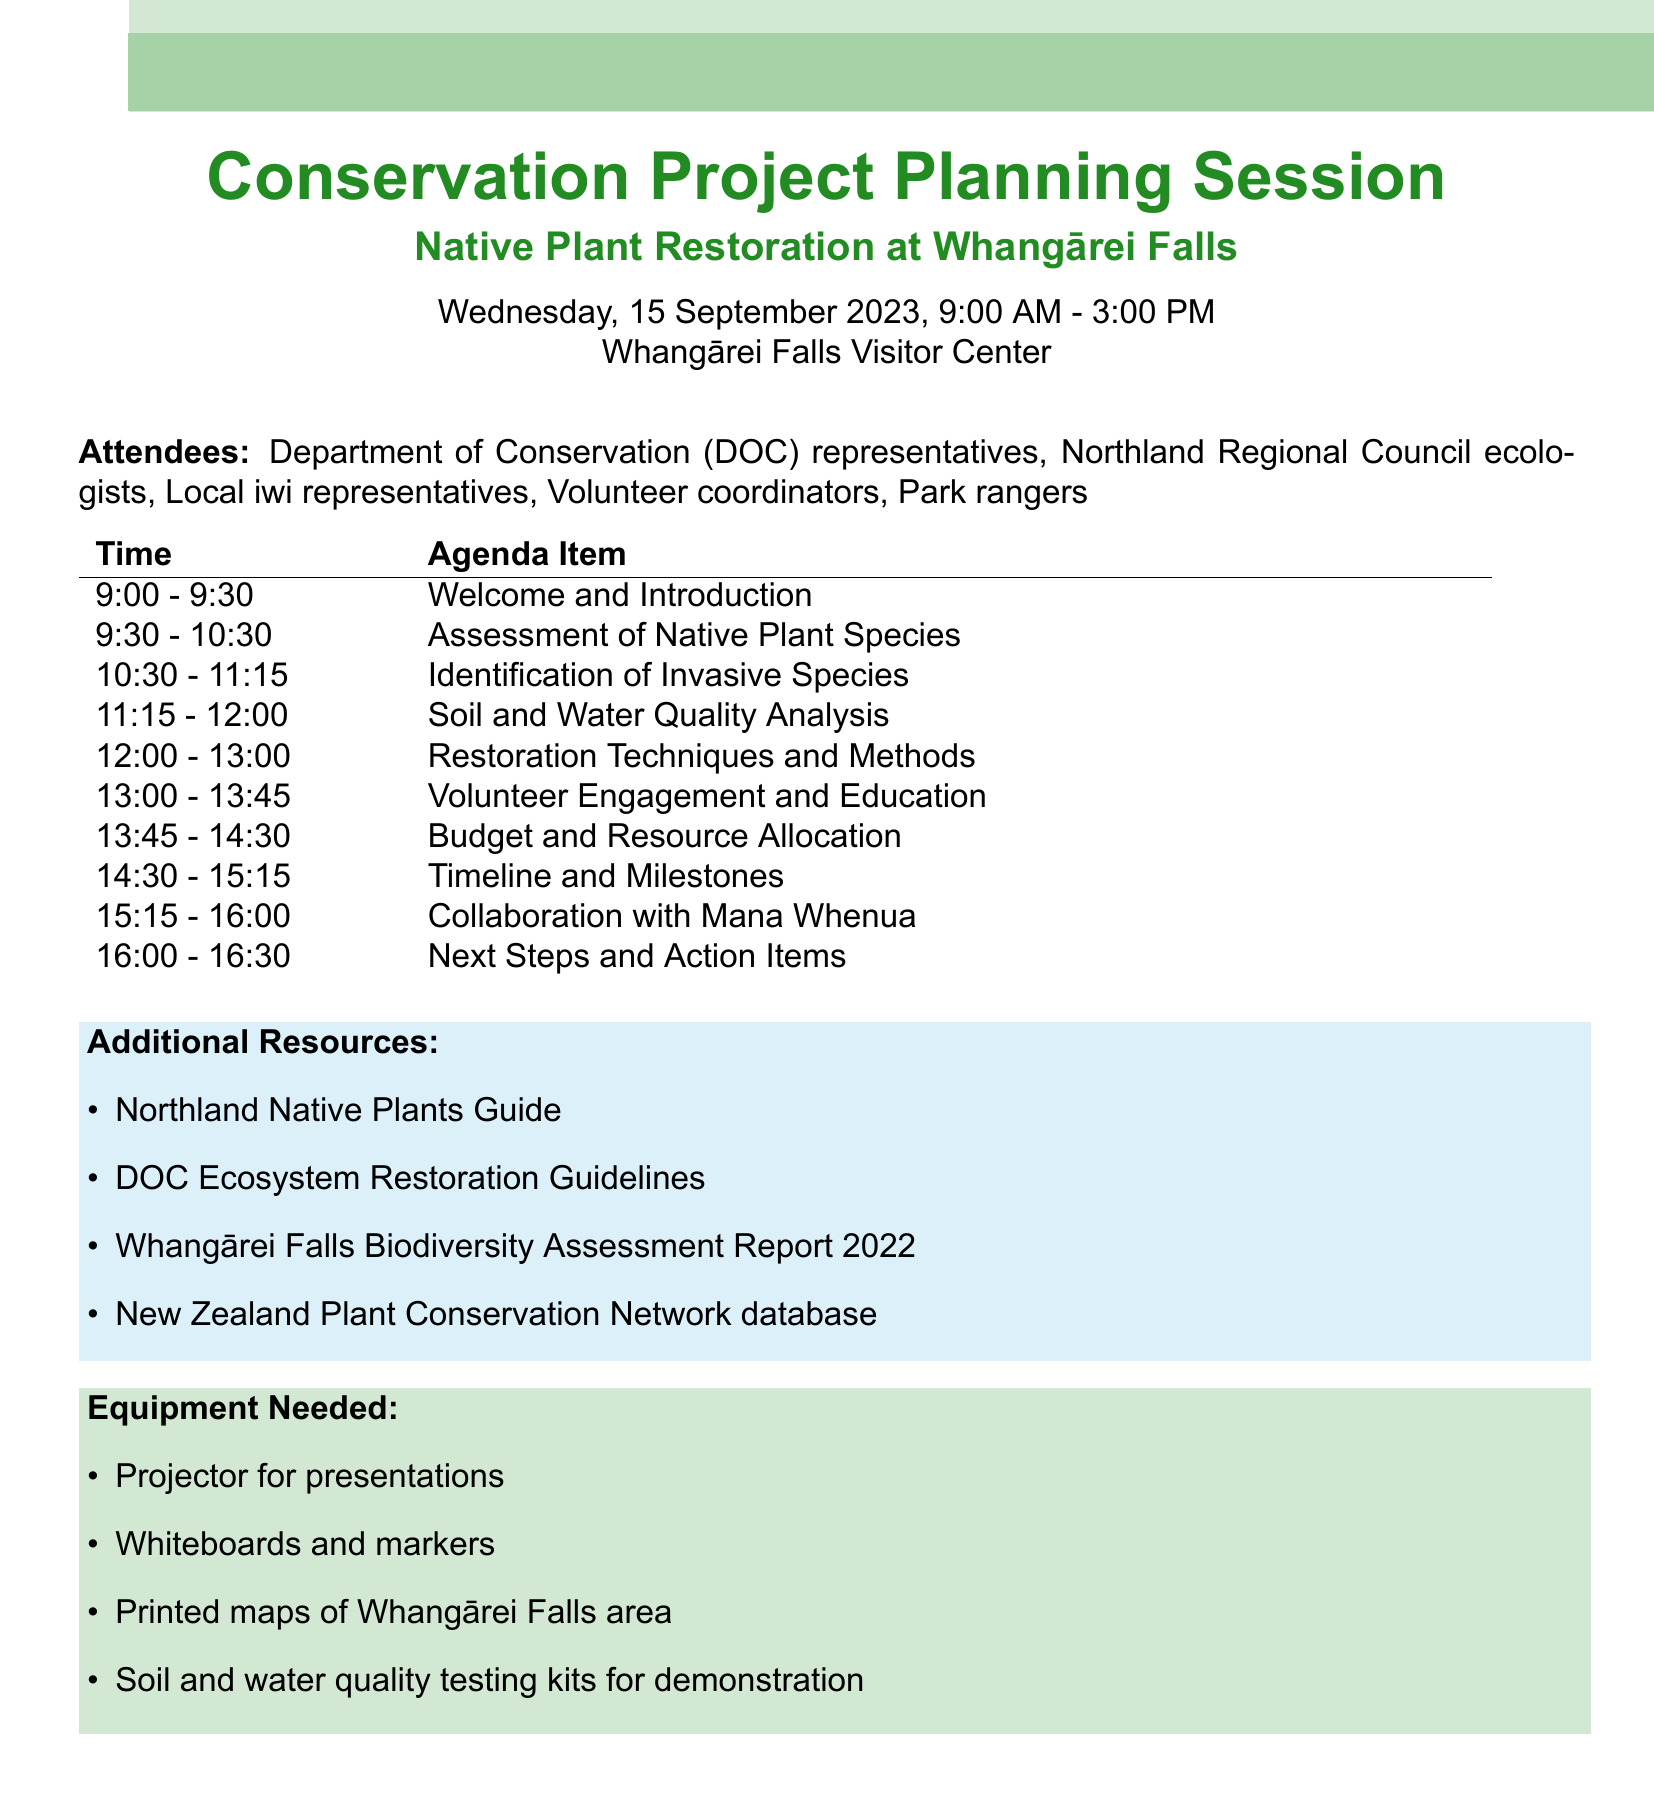What is the date of the conservation project planning session? The date is specifically mentioned in the document, providing a clear detail about when the meeting occurs.
Answer: Wednesday, 15 September 2023 How long is the assessment of native plant species session? The document provides the duration for each agenda item, highlighting the specific time allocation for this session.
Answer: 60 minutes Who are the attendees of the planning session? The document lists the different participant groups, making it easy to identify who will be present at the meeting.
Answer: Department of Conservation (DOC) representatives, Northland Regional Council ecologists, Local iwi representatives, Volunteer coordinators, Park rangers What is the main focus of the restoration techniques and methods agenda item? By looking at the details provided for this agenda item, we can identify its primary concentration.
Answer: Overview of planting strategies, erosion control measures, and long-term maintenance plans What equipment is needed for the session? The document explicitly lists out the equipment required for the meeting, detailing what will be necessary for the presentations and discussions.
Answer: Projector for presentations, Whiteboards and markers, Printed maps of Whangārei Falls area, Soil and water quality testing kits for demonstration What is the purpose of collaboration with Mana Whenua? The document provides insight into the significance and objectives of including Mana Whenua in the project discussions.
Answer: Integrating traditional ecological knowledge and ensuring cultural significance is respected 